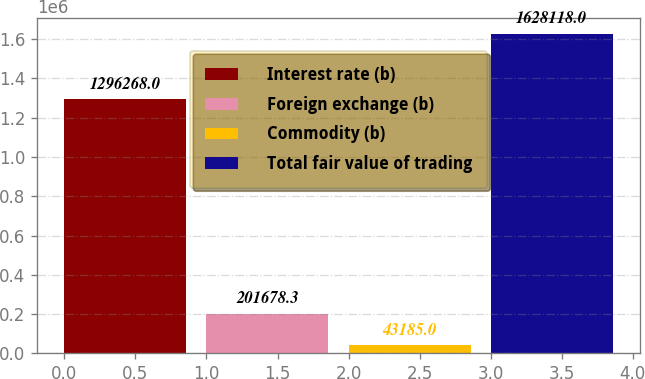Convert chart to OTSL. <chart><loc_0><loc_0><loc_500><loc_500><bar_chart><fcel>Interest rate (b)<fcel>Foreign exchange (b)<fcel>Commodity (b)<fcel>Total fair value of trading<nl><fcel>1.29627e+06<fcel>201678<fcel>43185<fcel>1.62812e+06<nl></chart> 